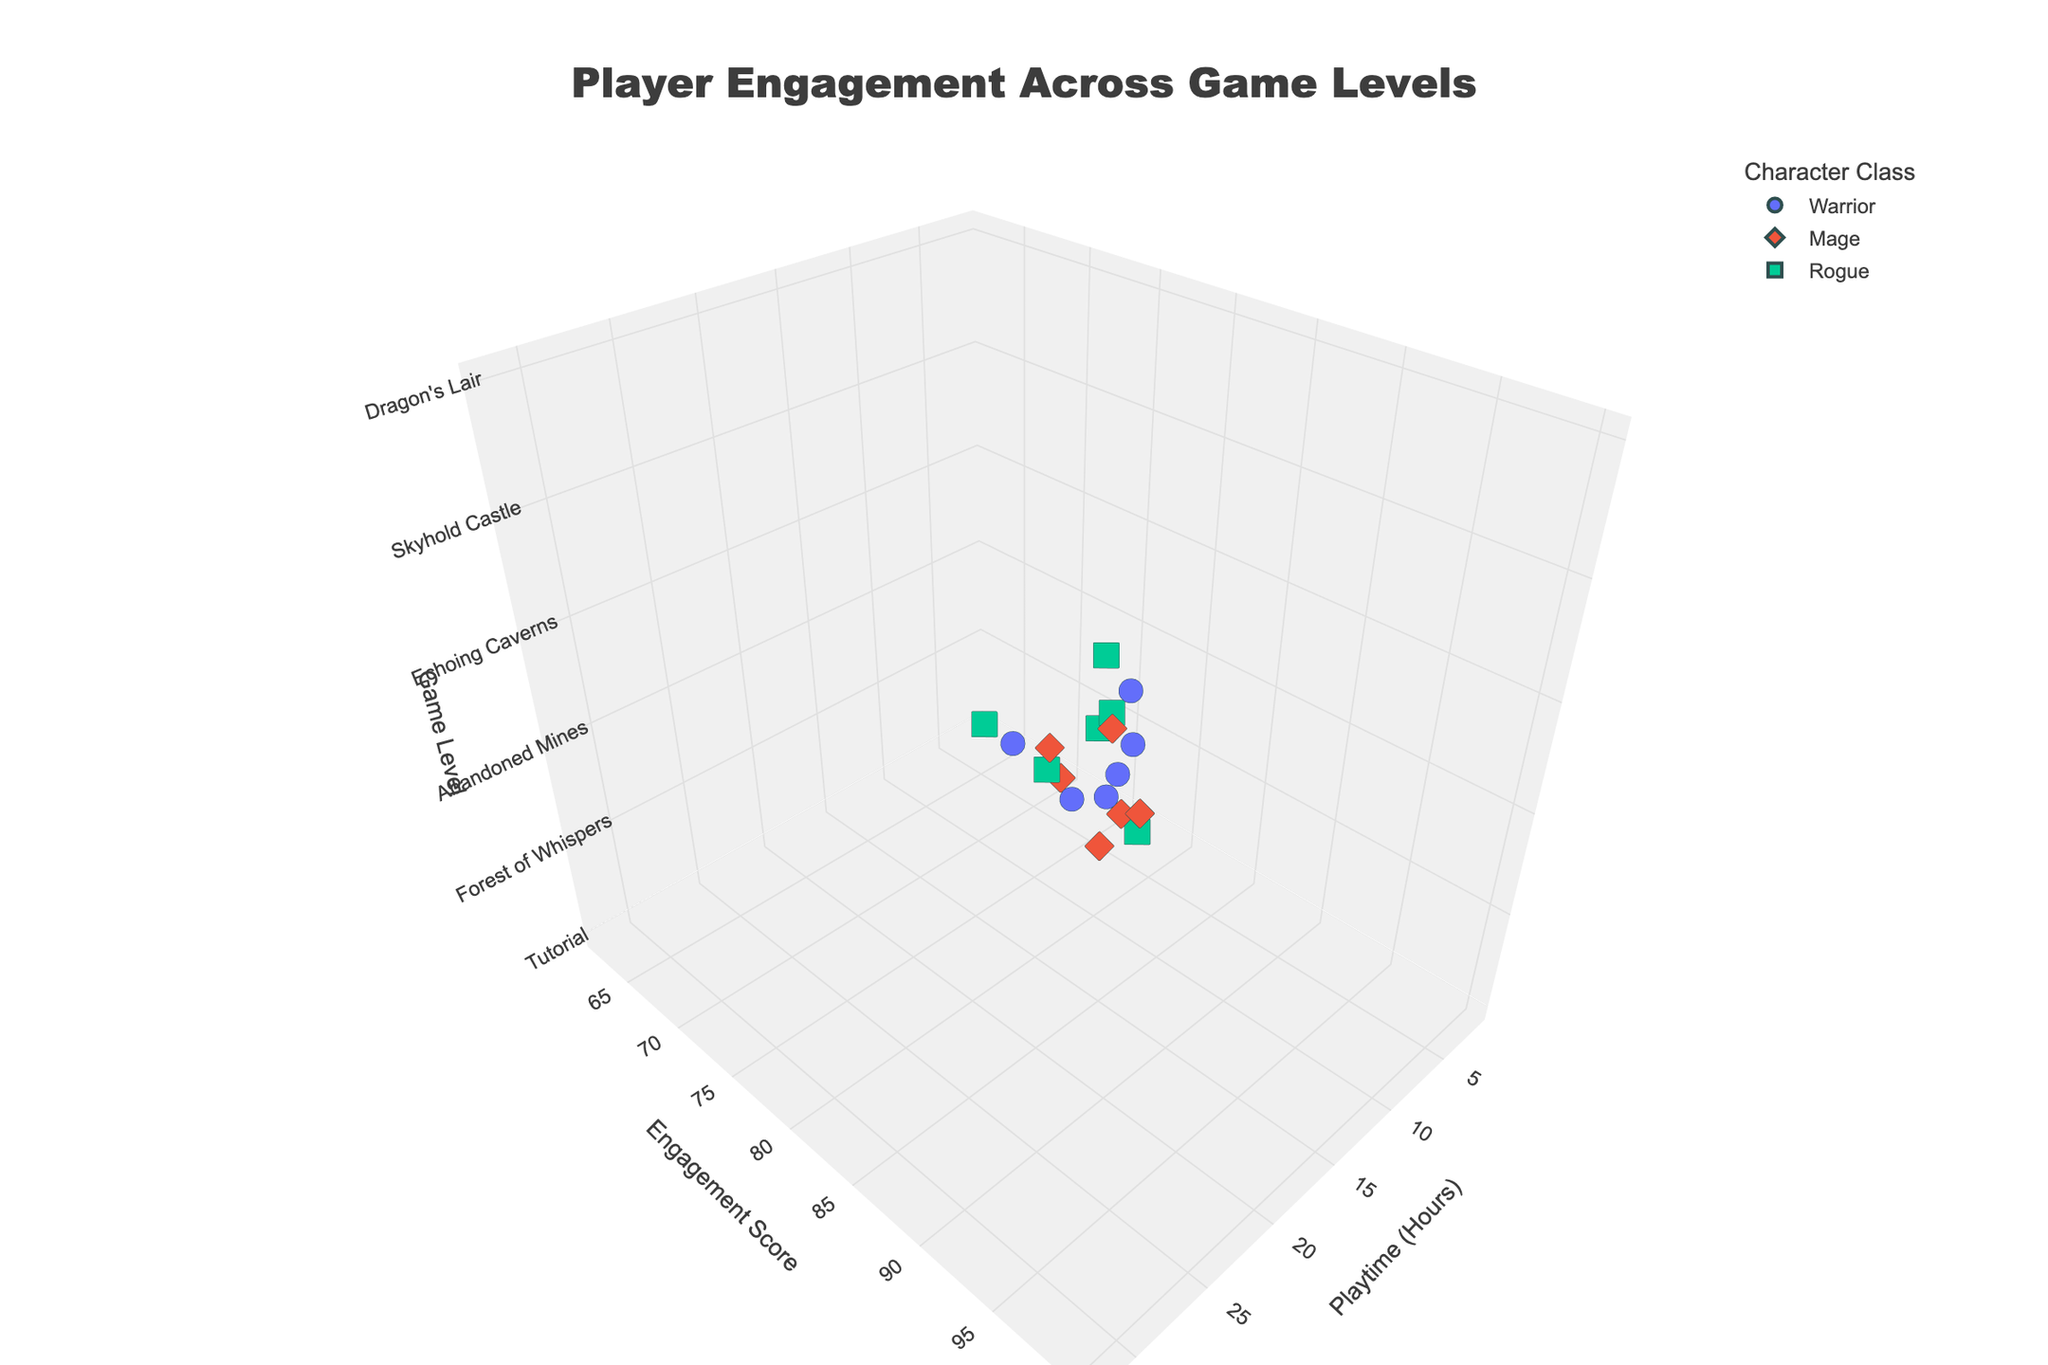What is the title of the figure? The title of the figure is "Player Engagement Across Game Levels," which is displayed at the top center of the plot.
Answer: Player Engagement Across Game Levels What is the relationship between playtime and engagement score for the Mage class? By examining the plot, we see that as playtime increases for the Mage class (colored as per the legend), the engagement score also increases. The points for Mage are higher up on the Engagement Score axis as Playtime Hours increase.
Answer: Positive correlation Which character class has the highest engagement score in Skyhold Castle? In the 3D plot, looking at the data points for Skyhold Castle on the z-axis, the Mage class has the highest engagement score of 98.
Answer: Mage How does the engagement score for the Rogue class in Abandoned Mines compare to the Warrior class in Echoing Caverns? In the plot, the Rogue class in Abandoned Mines has an engagement score of 88, and the Warrior class in Echoing Caverns has an engagement score of 90. Thus, the Rogue in Abandoned Mines has a lower engagement score compared to the Warrior in Echoing Caverns.
Answer: Lower What is the average engagement score for the Mage class across all game levels? To find the average engagement score for the Mage class, add their scores for each level: 70 (Tutorial) + 82 (Forest of Whispers) + 80 (Abandoned Mines) + 92 (Echoing Caverns) + 98 (Skyhold Castle) + 100 (Dragon's Lair). This sums to 522. Divide by the number of levels (6): 522/6 = 87.
Answer: 87 Which game level shows the greatest range in engagement scores among the character classes? By visually comparing the range of engagement scores for each game level, Skyhold Castle has the greatest range: Warrior (95), Mage (98), and Rogue (93). The range is 98 - 93 = 5. This is larger compared to the other levels.
Answer: Skyhold Castle Are engagement scores generally higher or lower in Dragon's Lair compared to Tutorial? By comparing the engagement scores for Dragon's Lair and Tutorial in the plot, we see that Dragon's Lair has higher scores (99, 100, 97) whereas Tutorial has lower scores (65, 70, 62). Thus, engagement scores are generally higher in Dragon's Lair.
Answer: Higher What trend can be observed for the engagement score as playtime increases across all character classes? The general trend observed in the 3D plot is that as playtime increases for all character classes, the engagement score tends to increase. Points higher on the playtime axis also tend to be higher on the engagement score axis.
Answer: Engagement increases with playtime Which level shows the highest engagement score for the Warrior class, and what is the value? Looking at the data points for the Warrior class, the highest engagement score is in Dragon's Lair, with a value of 99.
Answer: Dragon's Lair, 99 What is the difference in engagement score between Warrior and Mage in the Forest of Whispers? In the plot, the Warrior’s engagement score in the Forest of Whispers is 78, and the Mage’s is 82. The difference is 82 - 78 = 4.
Answer: 4 